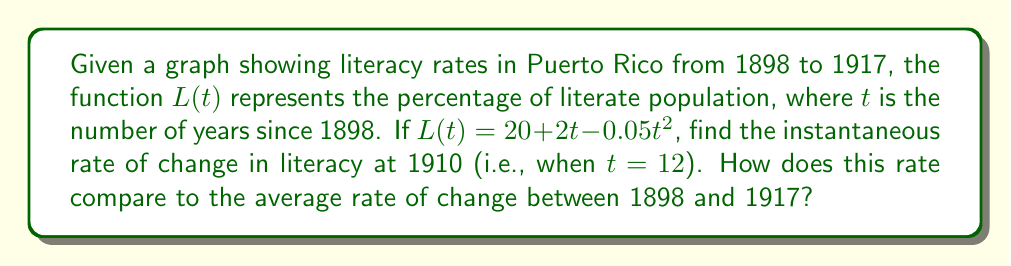Give your solution to this math problem. To solve this problem, we'll follow these steps:

1. Find the derivative of $L(t)$ to get the instantaneous rate of change function.
2. Evaluate the derivative at $t = 12$ (corresponding to 1910).
3. Calculate the average rate of change between 1898 and 1917.
4. Compare the instantaneous rate to the average rate.

Step 1: Find the derivative of $L(t)$
$$L(t) = 20 + 2t - 0.05t^2$$
$$L'(t) = 2 - 0.1t$$

Step 2: Evaluate the derivative at $t = 12$
$$L'(12) = 2 - 0.1(12) = 2 - 1.2 = 0.8$$

The instantaneous rate of change in 1910 is 0.8% per year.

Step 3: Calculate the average rate of change between 1898 and 1917
Average rate of change = $\frac{L(19) - L(0)}{19 - 0}$

$L(0) = 20 + 2(0) - 0.05(0)^2 = 20$
$L(19) = 20 + 2(19) - 0.05(19)^2 = 20 + 38 - 18.05 = 39.95$

Average rate of change = $\frac{39.95 - 20}{19} \approx 1.05$ % per year

Step 4: Compare the rates
The instantaneous rate of change in 1910 (0.8% per year) is lower than the average rate of change between 1898 and 1917 (1.05% per year). This suggests that the literacy rate was increasing more slowly in 1910 compared to the overall trend during the entire period.
Answer: The instantaneous rate of change in literacy at 1910 is 0.8% per year. This rate is lower than the average rate of change between 1898 and 1917, which is approximately 1.05% per year. 